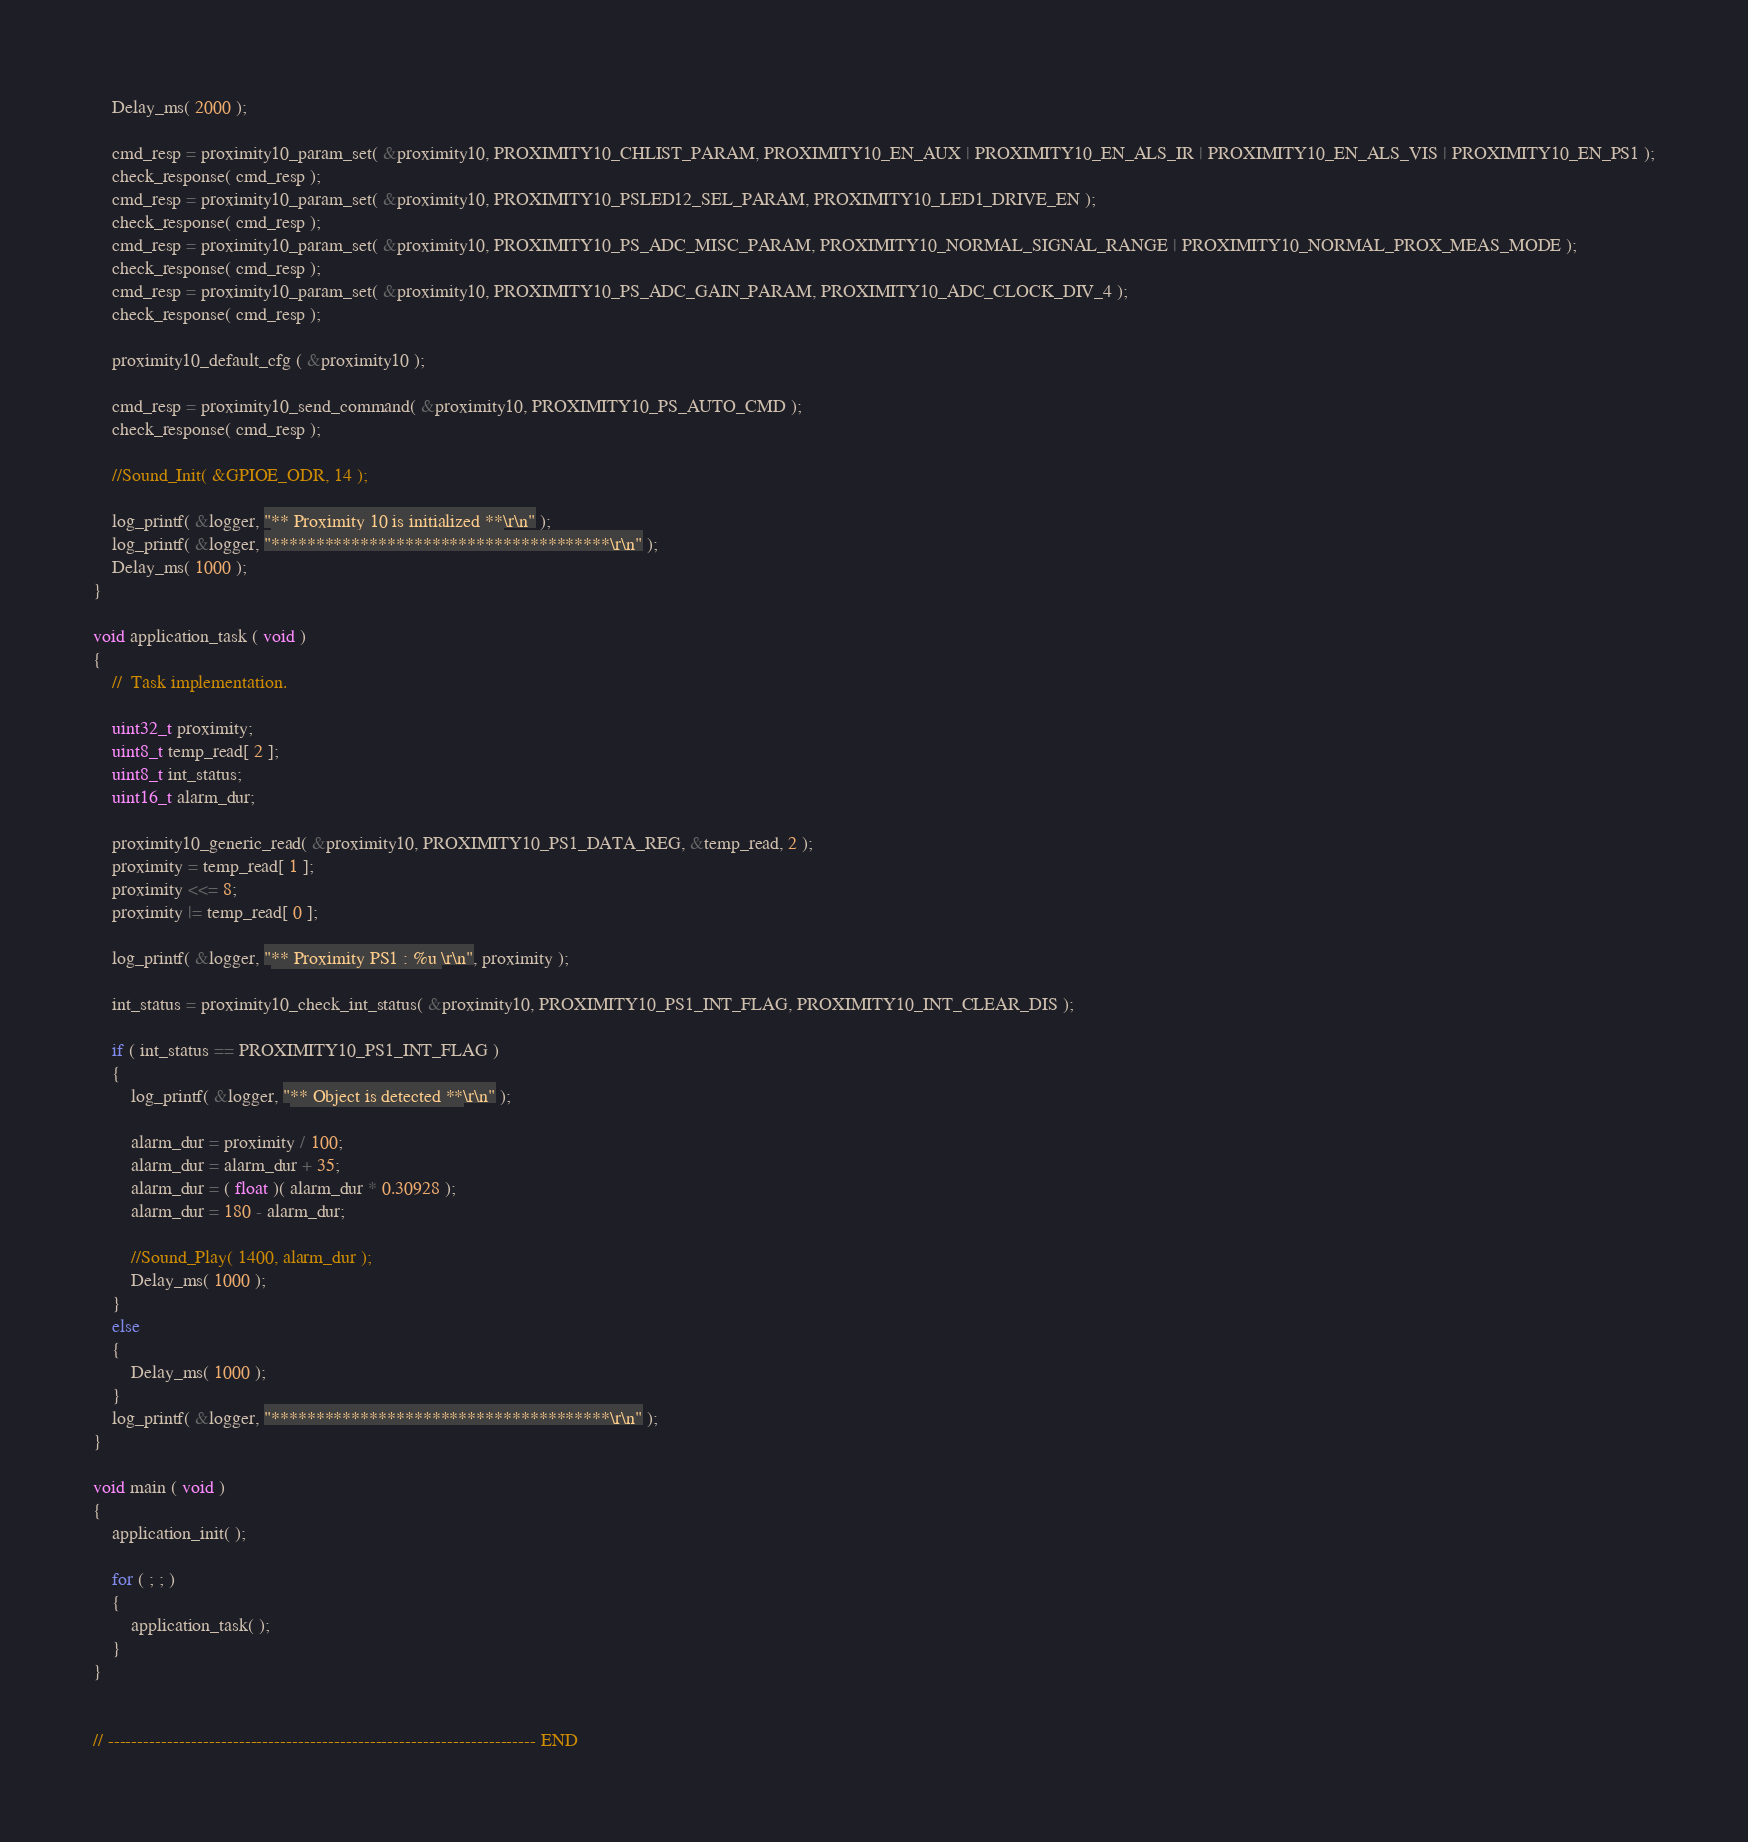Convert code to text. <code><loc_0><loc_0><loc_500><loc_500><_C_>    Delay_ms( 2000 );
    
    cmd_resp = proximity10_param_set( &proximity10, PROXIMITY10_CHLIST_PARAM, PROXIMITY10_EN_AUX | PROXIMITY10_EN_ALS_IR | PROXIMITY10_EN_ALS_VIS | PROXIMITY10_EN_PS1 );
    check_response( cmd_resp );
    cmd_resp = proximity10_param_set( &proximity10, PROXIMITY10_PSLED12_SEL_PARAM, PROXIMITY10_LED1_DRIVE_EN );
    check_response( cmd_resp );
    cmd_resp = proximity10_param_set( &proximity10, PROXIMITY10_PS_ADC_MISC_PARAM, PROXIMITY10_NORMAL_SIGNAL_RANGE | PROXIMITY10_NORMAL_PROX_MEAS_MODE );
    check_response( cmd_resp );
    cmd_resp = proximity10_param_set( &proximity10, PROXIMITY10_PS_ADC_GAIN_PARAM, PROXIMITY10_ADC_CLOCK_DIV_4 );
    check_response( cmd_resp );

    proximity10_default_cfg ( &proximity10 );

    cmd_resp = proximity10_send_command( &proximity10, PROXIMITY10_PS_AUTO_CMD );
    check_response( cmd_resp );
    
    //Sound_Init( &GPIOE_ODR, 14 );
    
    log_printf( &logger, "** Proximity 10 is initialized **\r\n" );
    log_printf( &logger, "**************************************\r\n" );
    Delay_ms( 1000 );
}

void application_task ( void )
{
    //  Task implementation.

    uint32_t proximity;
    uint8_t temp_read[ 2 ];
    uint8_t int_status;
    uint16_t alarm_dur;

    proximity10_generic_read( &proximity10, PROXIMITY10_PS1_DATA_REG, &temp_read, 2 );
    proximity = temp_read[ 1 ];
    proximity <<= 8;
    proximity |= temp_read[ 0 ];
    
    log_printf( &logger, "** Proximity PS1 : %u \r\n", proximity );
    
    int_status = proximity10_check_int_status( &proximity10, PROXIMITY10_PS1_INT_FLAG, PROXIMITY10_INT_CLEAR_DIS );
    
    if ( int_status == PROXIMITY10_PS1_INT_FLAG )
    {
        log_printf( &logger, "** Object is detected **\r\n" );
        
        alarm_dur = proximity / 100;
        alarm_dur = alarm_dur + 35;
        alarm_dur = ( float )( alarm_dur * 0.30928 );
        alarm_dur = 180 - alarm_dur;
        
        //Sound_Play( 1400, alarm_dur );
        Delay_ms( 1000 );
    }
    else
    {
        Delay_ms( 1000 );
    }
    log_printf( &logger, "**************************************\r\n" );
}

void main ( void )
{
    application_init( );

    for ( ; ; )
    {
        application_task( );
    }
}


// ------------------------------------------------------------------------ END
</code> 